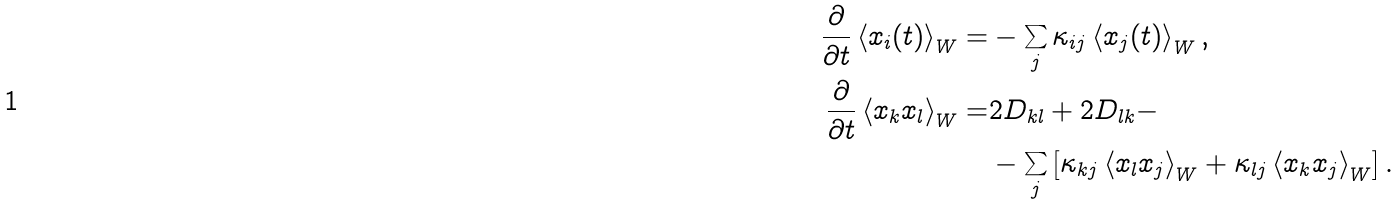Convert formula to latex. <formula><loc_0><loc_0><loc_500><loc_500>\frac { \partial } { \partial t } \left \langle x _ { i } ( t ) \right \rangle _ { W } = & - \sum _ { j } \kappa _ { i j } \left \langle x _ { j } ( t ) \right \rangle _ { W } , \\ \frac { \partial } { \partial t } \left \langle x _ { k } x _ { l } \right \rangle _ { W } = & 2 D _ { k l } + 2 D _ { l k } - \\ & - \sum _ { j } \left [ \kappa _ { k j } \left \langle x _ { l } x _ { j } \right \rangle _ { W } + \kappa _ { l j } \left \langle x _ { k } x _ { j } \right \rangle _ { W } \right ] .</formula> 